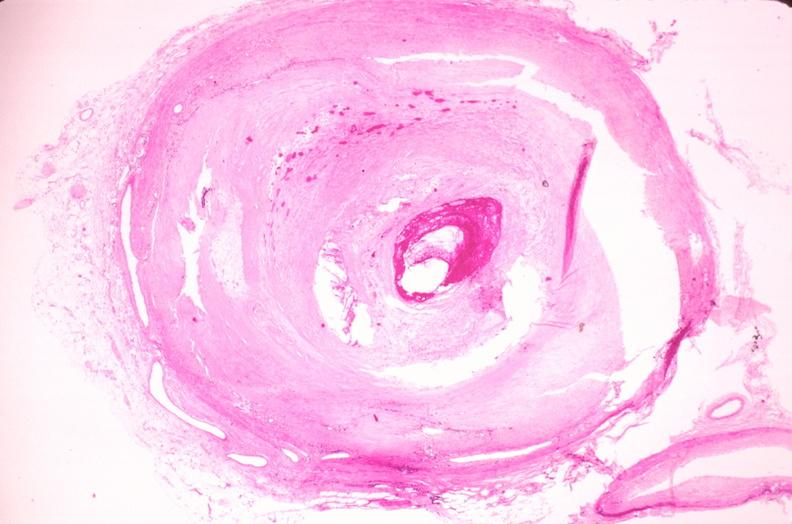what does this image show?
Answer the question using a single word or phrase. Coronary artery atherosclerosis 